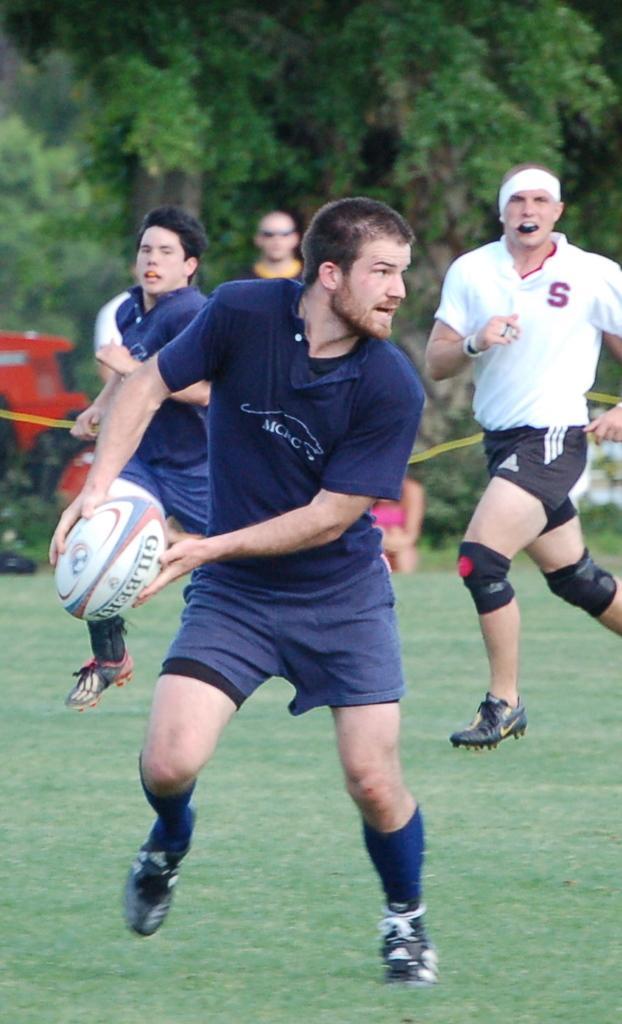How would you summarize this image in a sentence or two? in this image i can a man running holding a ball in his hand. behind him there are more people running on the grass. at the back there are many trees. 